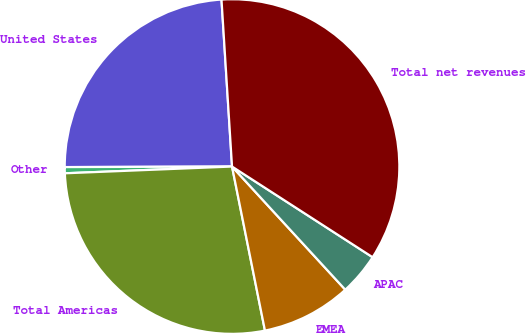<chart> <loc_0><loc_0><loc_500><loc_500><pie_chart><fcel>United States<fcel>Other<fcel>Total Americas<fcel>EMEA<fcel>APAC<fcel>Total net revenues<nl><fcel>24.05%<fcel>0.59%<fcel>27.51%<fcel>8.68%<fcel>4.05%<fcel>35.12%<nl></chart> 